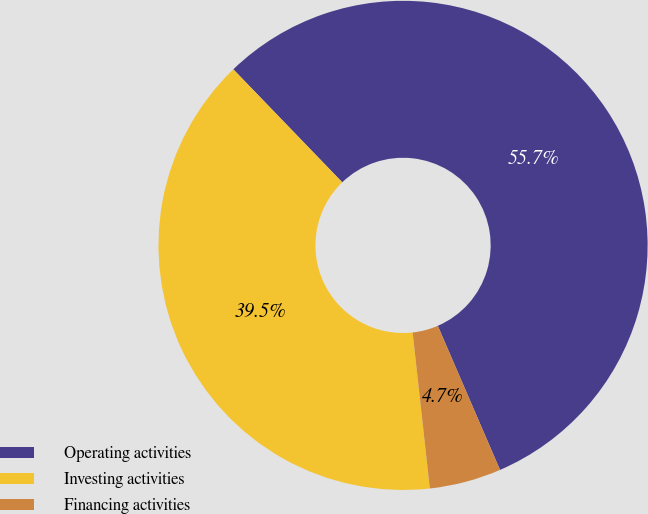Convert chart. <chart><loc_0><loc_0><loc_500><loc_500><pie_chart><fcel>Operating activities<fcel>Investing activities<fcel>Financing activities<nl><fcel>55.72%<fcel>39.54%<fcel>4.74%<nl></chart> 